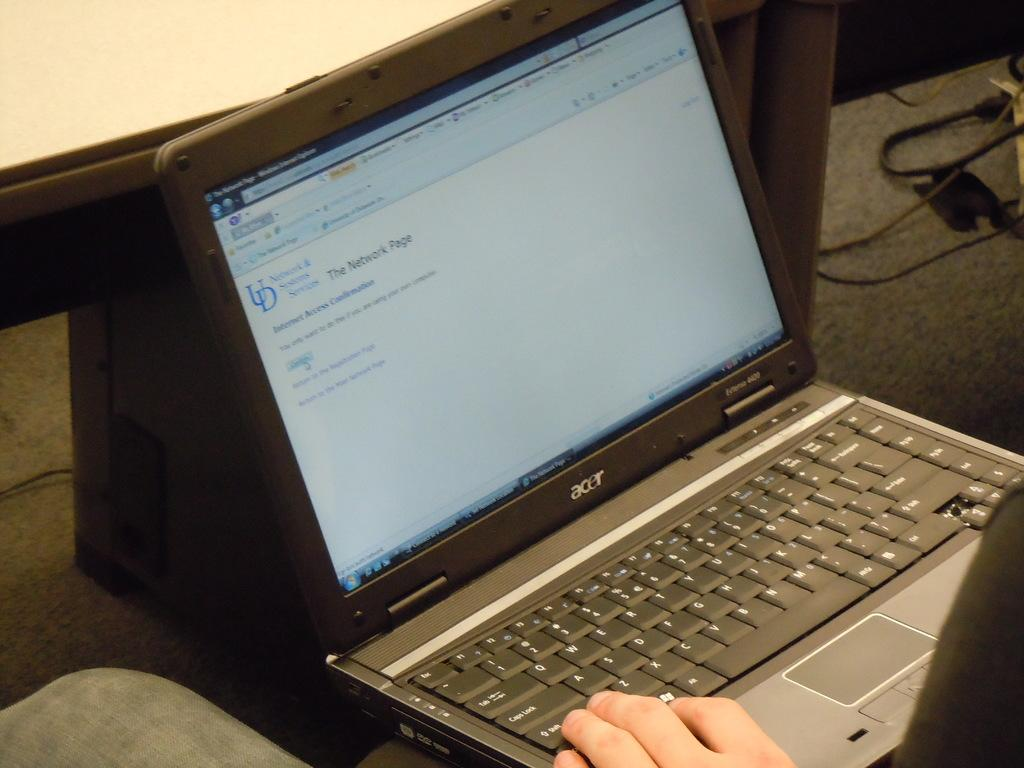Provide a one-sentence caption for the provided image. A person is using an Acer laptop connected to the internet. 